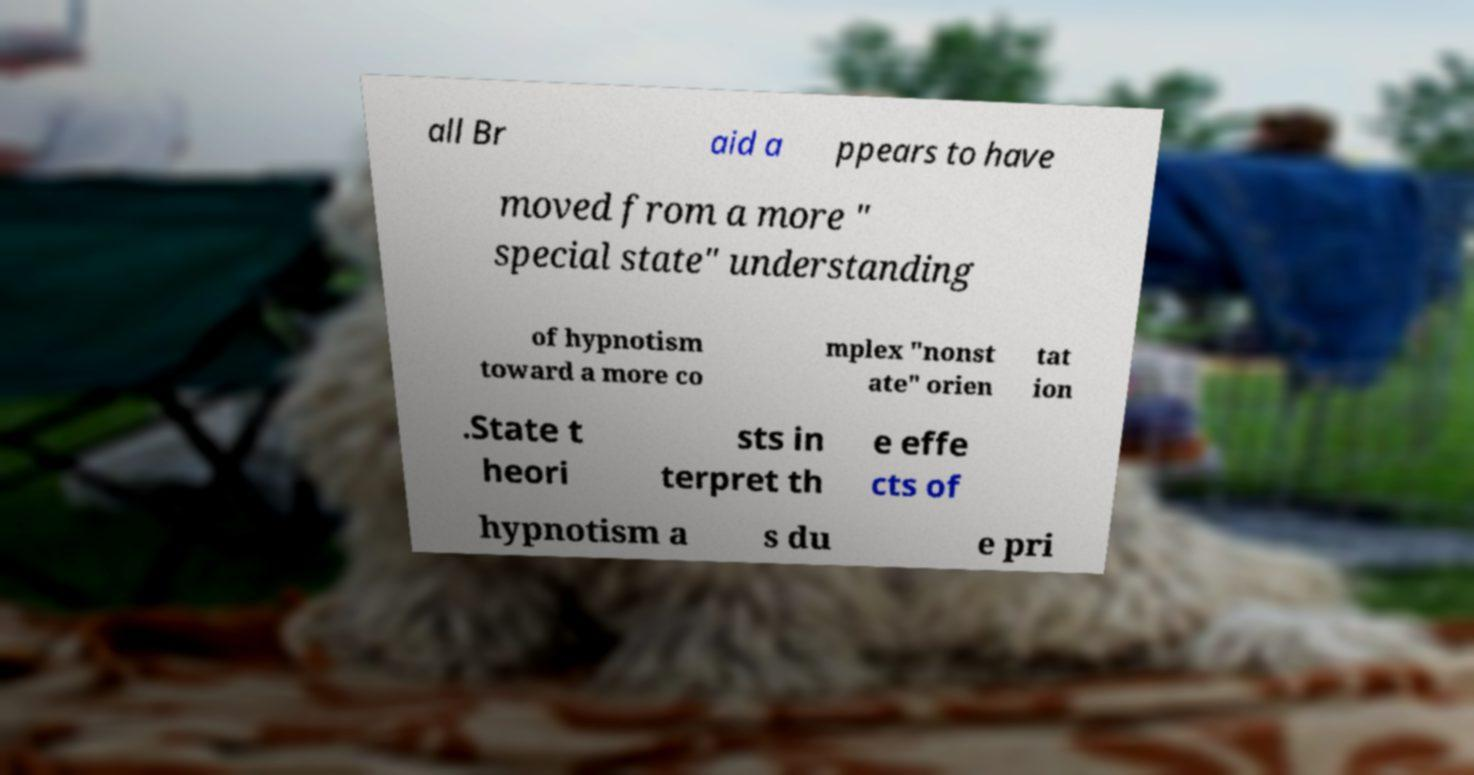For documentation purposes, I need the text within this image transcribed. Could you provide that? all Br aid a ppears to have moved from a more " special state" understanding of hypnotism toward a more co mplex "nonst ate" orien tat ion .State t heori sts in terpret th e effe cts of hypnotism a s du e pri 